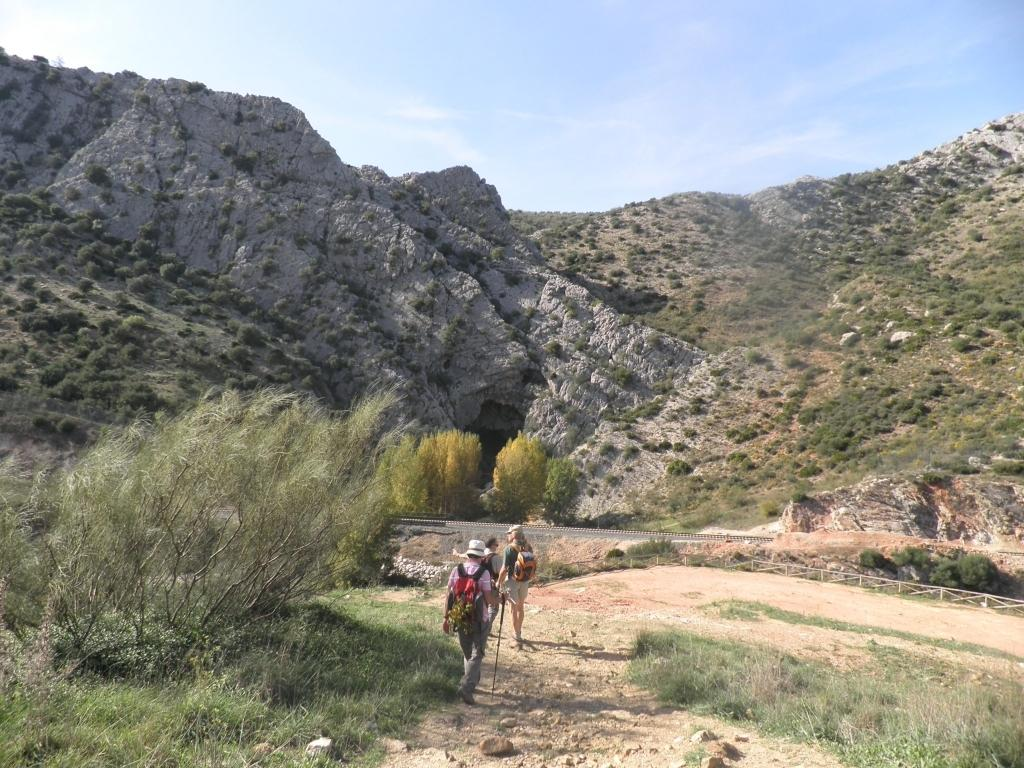What are the people in the image doing? The people in the image are walking. What are the people wearing on their backs? The people are wearing bags. What type of vegetation can be seen in the image? There are trees and green grass visible in the image. What type of landscape feature is present in the image? There are mountains in the image. What is the color of the sky in the image? The sky is a combination of white and blue colors. What type of cherry is being used as a prop in the image? There is no cherry present in the image. Can you tell me how the people in the image are turning around? The people in the image are not turning around; they are walking forward. 